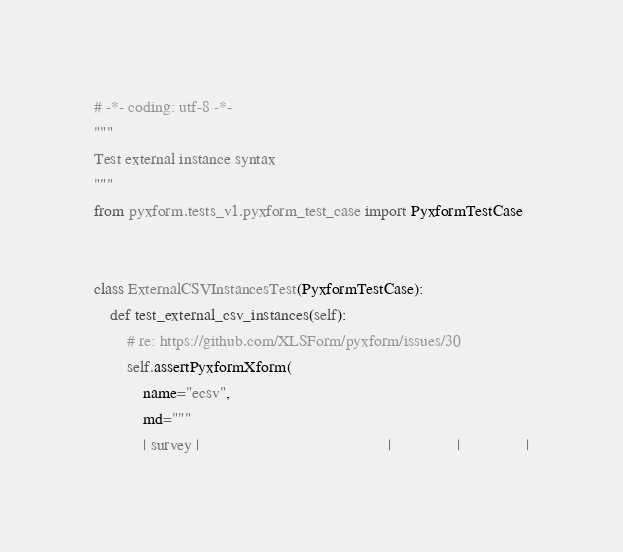Convert code to text. <code><loc_0><loc_0><loc_500><loc_500><_Python_># -*- coding: utf-8 -*-
"""
Test external instance syntax
"""
from pyxform.tests_v1.pyxform_test_case import PyxformTestCase


class ExternalCSVInstancesTest(PyxformTestCase):
    def test_external_csv_instances(self):
        # re: https://github.com/XLSForm/pyxform/issues/30
        self.assertPyxformXform(
            name="ecsv",
            md="""
            | survey |                                              |                |                |</code> 